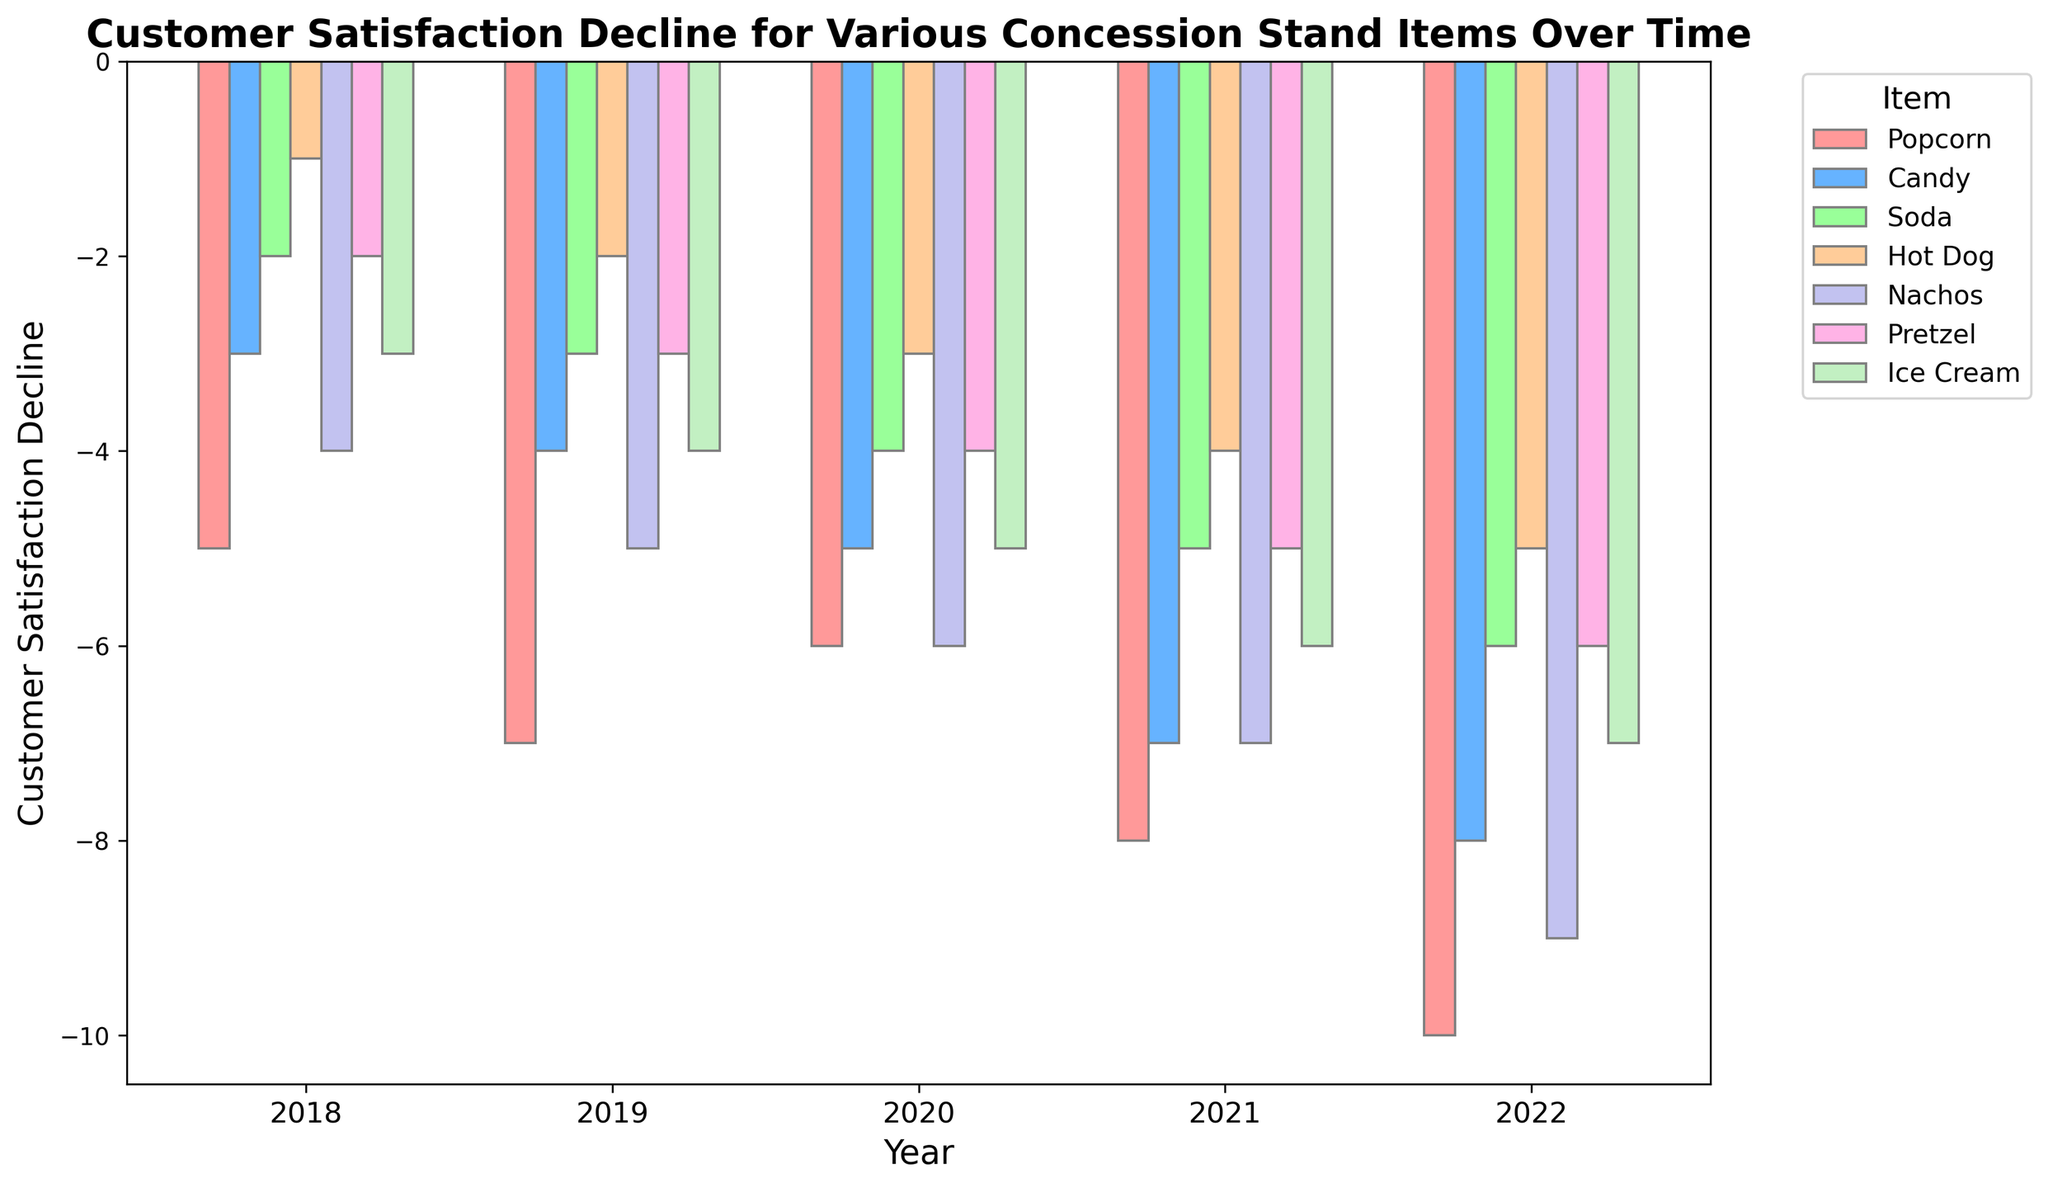what year saw the greatest decline in customer satisfaction for popcorn? Look at the bar heights for popcorn across all years and identify the year with the lowest value. Popcorn had the greatest decline in customer satisfaction in 2022 with a value of -10.
Answer: 2022 compare the customer satisfaction decline of soda and pretzel in 2018 Find the heights of the bars representing soda and pretzel for the year 2018. For 2018, soda had a decline of -2, while pretzel had a decline of -2.
Answer: same decline which item had the least decline in customer satisfaction in 2021? Look at all the bars for the year 2021 and identify the shortest bar. Hot Dog had the least decline in 2021 at -4.
Answer: Hot Dog what is the average customer satisfaction decline for nachos over the 5 years? Add the decline values for nachos from 2018 to 2022 and divide by the number of years. (-4 + -5 + -6 + -7 + -9) / 5 = -6.2.
Answer: -6.2 how does the customer satisfaction decline of candy in 2020 compare to that of ice cream in 2020? Identify and compare the heights of the bars for candy and ice cream in 2020. For 2020, candy had a decline of -5, and ice cream had a decline of -5. Thus, their declines are the same.
Answer: same decline which item had the highest increase in customer satisfaction decline from 2018 to 2022? Calculate the difference in decline values from 2018 to 2022 for all items and identify the largest increase. Popcorn had an increase of -10 - (-5) = -5, Candy had an increase of -8 - (-3) = -5, Soda had an increase of -6 - (-2) = -4, Hot Dog had an increase of -5 - (-1) = -4, Nachos had an increase of -9 - (-4) = -5, Pretzel had an increase of -6 - (-2) = -4, and Ice Cream had an increase of -7 - (-3) = -4. Since -5 is the largest value and affects two items, Popcorn, Candy, and Nachos all share the highest increase.
Answer: Popcorn, Candy, and Nachos what is the overall trend of customer satisfaction decline for soda from 2018 to 2022? Identify the decline values of soda for each year from 2018 to 2022. The values are -2, -3, -4, -5, and -6, respectively. Since the values continually increase in magnitude, this shows a continuous decline.
Answer: continuous decline which two items had the closest customer satisfaction decline in 2019? Compare the decline values for all items in 2019 and find the pair with the smallest difference. For 2019, Popcorn: -7, Candy: -4, Soda: -3, Hot Dog: -2, Nachos: -5, Pretzel: -3, Ice Cream: -4. Soda and Pretzel both had a decline of -3, which makes them the closest.
Answer: Soda and Pretzel 